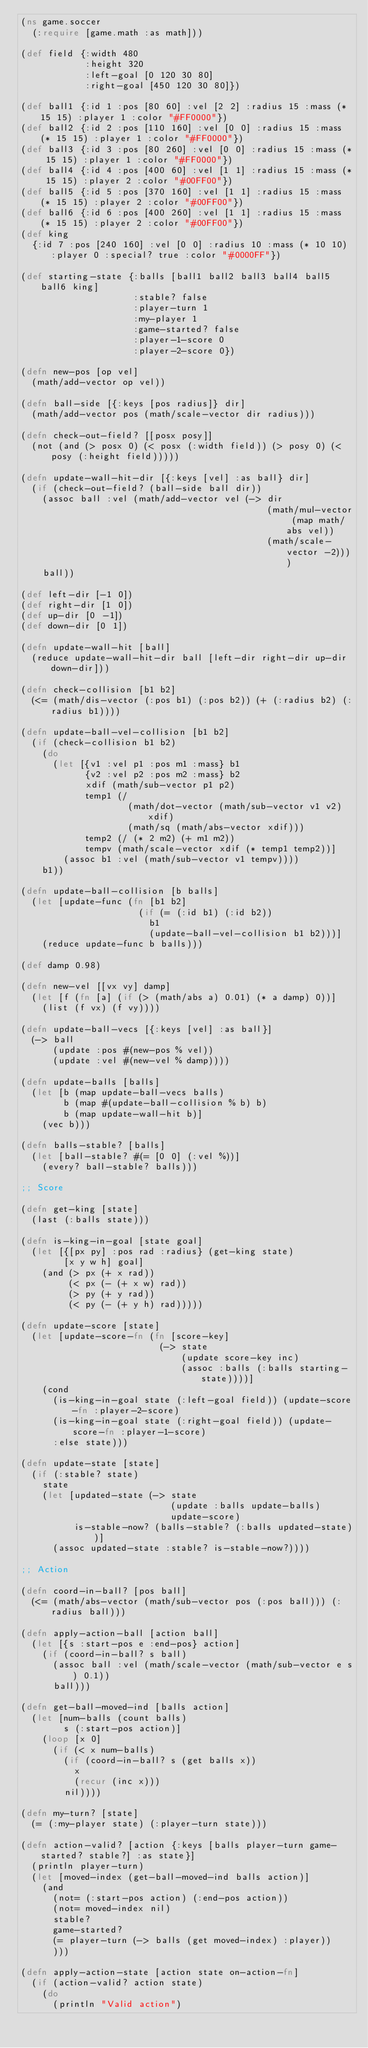<code> <loc_0><loc_0><loc_500><loc_500><_Clojure_>(ns game.soccer
  (:require [game.math :as math]))

(def field {:width 480
            :height 320
            :left-goal [0 120 30 80]
            :right-goal [450 120 30 80]})

(def ball1 {:id 1 :pos [80 60] :vel [2 2] :radius 15 :mass (* 15 15) :player 1 :color "#FF0000"})
(def ball2 {:id 2 :pos [110 160] :vel [0 0] :radius 15 :mass (* 15 15) :player 1 :color "#FF0000"})
(def ball3 {:id 3 :pos [80 260] :vel [0 0] :radius 15 :mass (* 15 15) :player 1 :color "#FF0000"})
(def ball4 {:id 4 :pos [400 60] :vel [1 1] :radius 15 :mass (* 15 15) :player 2 :color "#00FF00"})
(def ball5 {:id 5 :pos [370 160] :vel [1 1] :radius 15 :mass (* 15 15) :player 2 :color "#00FF00"})
(def ball6 {:id 6 :pos [400 260] :vel [1 1] :radius 15 :mass (* 15 15) :player 2 :color "#00FF00"})
(def king
  {:id 7 :pos [240 160] :vel [0 0] :radius 10 :mass (* 10 10) :player 0 :special? true :color "#0000FF"})

(def starting-state {:balls [ball1 ball2 ball3 ball4 ball5 ball6 king]
                     :stable? false
                     :player-turn 1
                     :my-player 1
                     :game-started? false
                     :player-1-score 0
                     :player-2-score 0})

(defn new-pos [op vel]
  (math/add-vector op vel))

(defn ball-side [{:keys [pos radius]} dir]
  (math/add-vector pos (math/scale-vector dir radius)))

(defn check-out-field? [[posx posy]]
  (not (and (> posx 0) (< posx (:width field)) (> posy 0) (< posy (:height field)))))

(defn update-wall-hit-dir [{:keys [vel] :as ball} dir]
  (if (check-out-field? (ball-side ball dir))
    (assoc ball :vel (math/add-vector vel (-> dir
                                              (math/mul-vector (map math/abs vel))
                                              (math/scale-vector -2))))
    ball))

(def left-dir [-1 0])
(def right-dir [1 0])
(def up-dir [0 -1])
(def down-dir [0 1])

(defn update-wall-hit [ball]
  (reduce update-wall-hit-dir ball [left-dir right-dir up-dir down-dir]))

(defn check-collision [b1 b2]
  (<= (math/dis-vector (:pos b1) (:pos b2)) (+ (:radius b2) (:radius b1))))

(defn update-ball-vel-collision [b1 b2]
  (if (check-collision b1 b2)
    (do
      (let [{v1 :vel p1 :pos m1 :mass} b1
            {v2 :vel p2 :pos m2 :mass} b2
            xdif (math/sub-vector p1 p2)
            temp1 (/
                    (math/dot-vector (math/sub-vector v1 v2) xdif)
                    (math/sq (math/abs-vector xdif)))
            temp2 (/ (* 2 m2) (+ m1 m2))
            tempv (math/scale-vector xdif (* temp1 temp2))]
        (assoc b1 :vel (math/sub-vector v1 tempv))))
    b1))

(defn update-ball-collision [b balls]
  (let [update-func (fn [b1 b2]
                      (if (= (:id b1) (:id b2))
                        b1
                        (update-ball-vel-collision b1 b2)))]
    (reduce update-func b balls)))

(def damp 0.98)

(defn new-vel [[vx vy] damp]
  (let [f (fn [a] (if (> (math/abs a) 0.01) (* a damp) 0))]
    (list (f vx) (f vy))))

(defn update-ball-vecs [{:keys [vel] :as ball}]
  (-> ball
      (update :pos #(new-pos % vel))
      (update :vel #(new-vel % damp))))

(defn update-balls [balls]
  (let [b (map update-ball-vecs balls)
        b (map #(update-ball-collision % b) b)
        b (map update-wall-hit b)]
    (vec b)))

(defn balls-stable? [balls]
  (let [ball-stable? #(= [0 0] (:vel %))]
    (every? ball-stable? balls)))

;; Score

(defn get-king [state]
  (last (:balls state)))

(defn is-king-in-goal [state goal]
  (let [{[px py] :pos rad :radius} (get-king state)
        [x y w h] goal]
    (and (> px (+ x rad))
         (< px (- (+ x w) rad))
         (> py (+ y rad))
         (< py (- (+ y h) rad)))))

(defn update-score [state]
  (let [update-score-fn (fn [score-key]
                          (-> state
                              (update score-key inc)
                              (assoc :balls (:balls starting-state))))]
    (cond
      (is-king-in-goal state (:left-goal field)) (update-score-fn :player-2-score)
      (is-king-in-goal state (:right-goal field)) (update-score-fn :player-1-score)
      :else state)))

(defn update-state [state]
  (if (:stable? state)
    state
    (let [updated-state (-> state
                            (update :balls update-balls)
                            update-score)
          is-stable-now? (balls-stable? (:balls updated-state))]
      (assoc updated-state :stable? is-stable-now?))))

;; Action

(defn coord-in-ball? [pos ball]
  (<= (math/abs-vector (math/sub-vector pos (:pos ball))) (:radius ball)))

(defn apply-action-ball [action ball]
  (let [{s :start-pos e :end-pos} action]
    (if (coord-in-ball? s ball)
      (assoc ball :vel (math/scale-vector (math/sub-vector e s) 0.1))
      ball)))

(defn get-ball-moved-ind [balls action]
  (let [num-balls (count balls)
        s (:start-pos action)]
    (loop [x 0]
      (if (< x num-balls)
        (if (coord-in-ball? s (get balls x))
          x
          (recur (inc x)))
        nil))))

(defn my-turn? [state]
  (= (:my-player state) (:player-turn state)))

(defn action-valid? [action {:keys [balls player-turn game-started? stable?] :as state}]
  (println player-turn)
  (let [moved-index (get-ball-moved-ind balls action)]
    (and
      (not= (:start-pos action) (:end-pos action))
      (not= moved-index nil)
      stable?
      game-started?
      (= player-turn (-> balls (get moved-index) :player))
      )))

(defn apply-action-state [action state on-action-fn]
  (if (action-valid? action state)
    (do
      (println "Valid action")</code> 